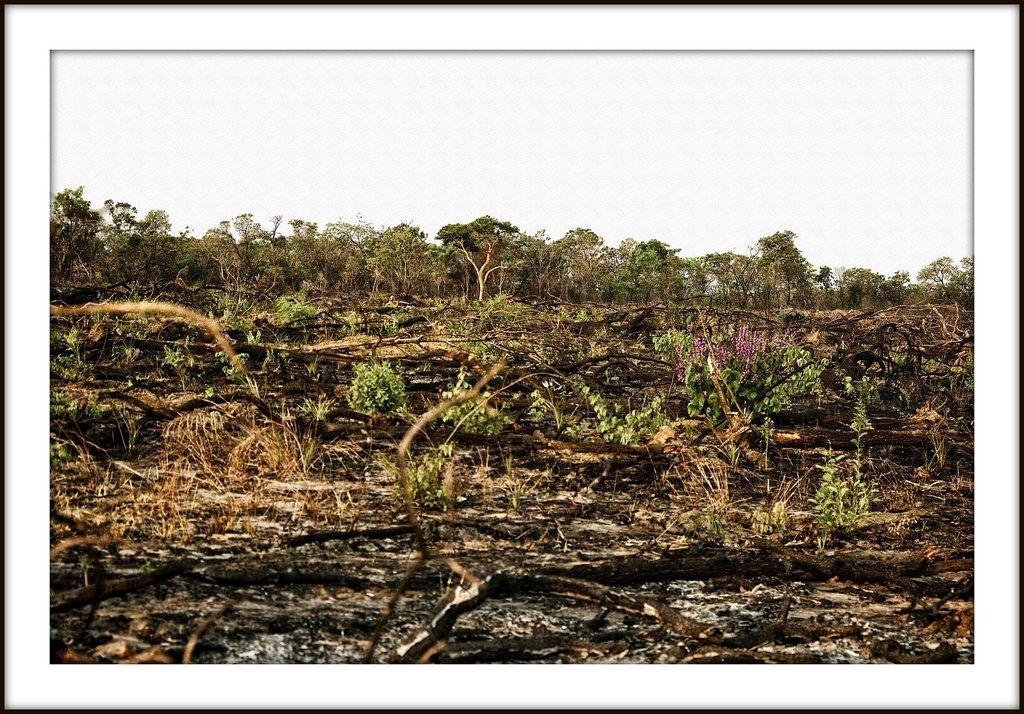What type of setting is depicted in the image? The image is an outside view. What can be seen at the bottom of the image? The ground is visible at the bottom of the image. What type of vegetation is present in the image? There are plants and trees in the image. What is visible at the top of the image? The sky is visible at the top of the image. Has the image been altered in any way? Yes, the image has been edited. What color is the ink spilled on the ground in the image? There is no ink spilled on the ground in the image; it is a natural outdoor scene with plants, trees, and sky. Can you see any donkeys in the image? No, there are no donkeys present in the image. 